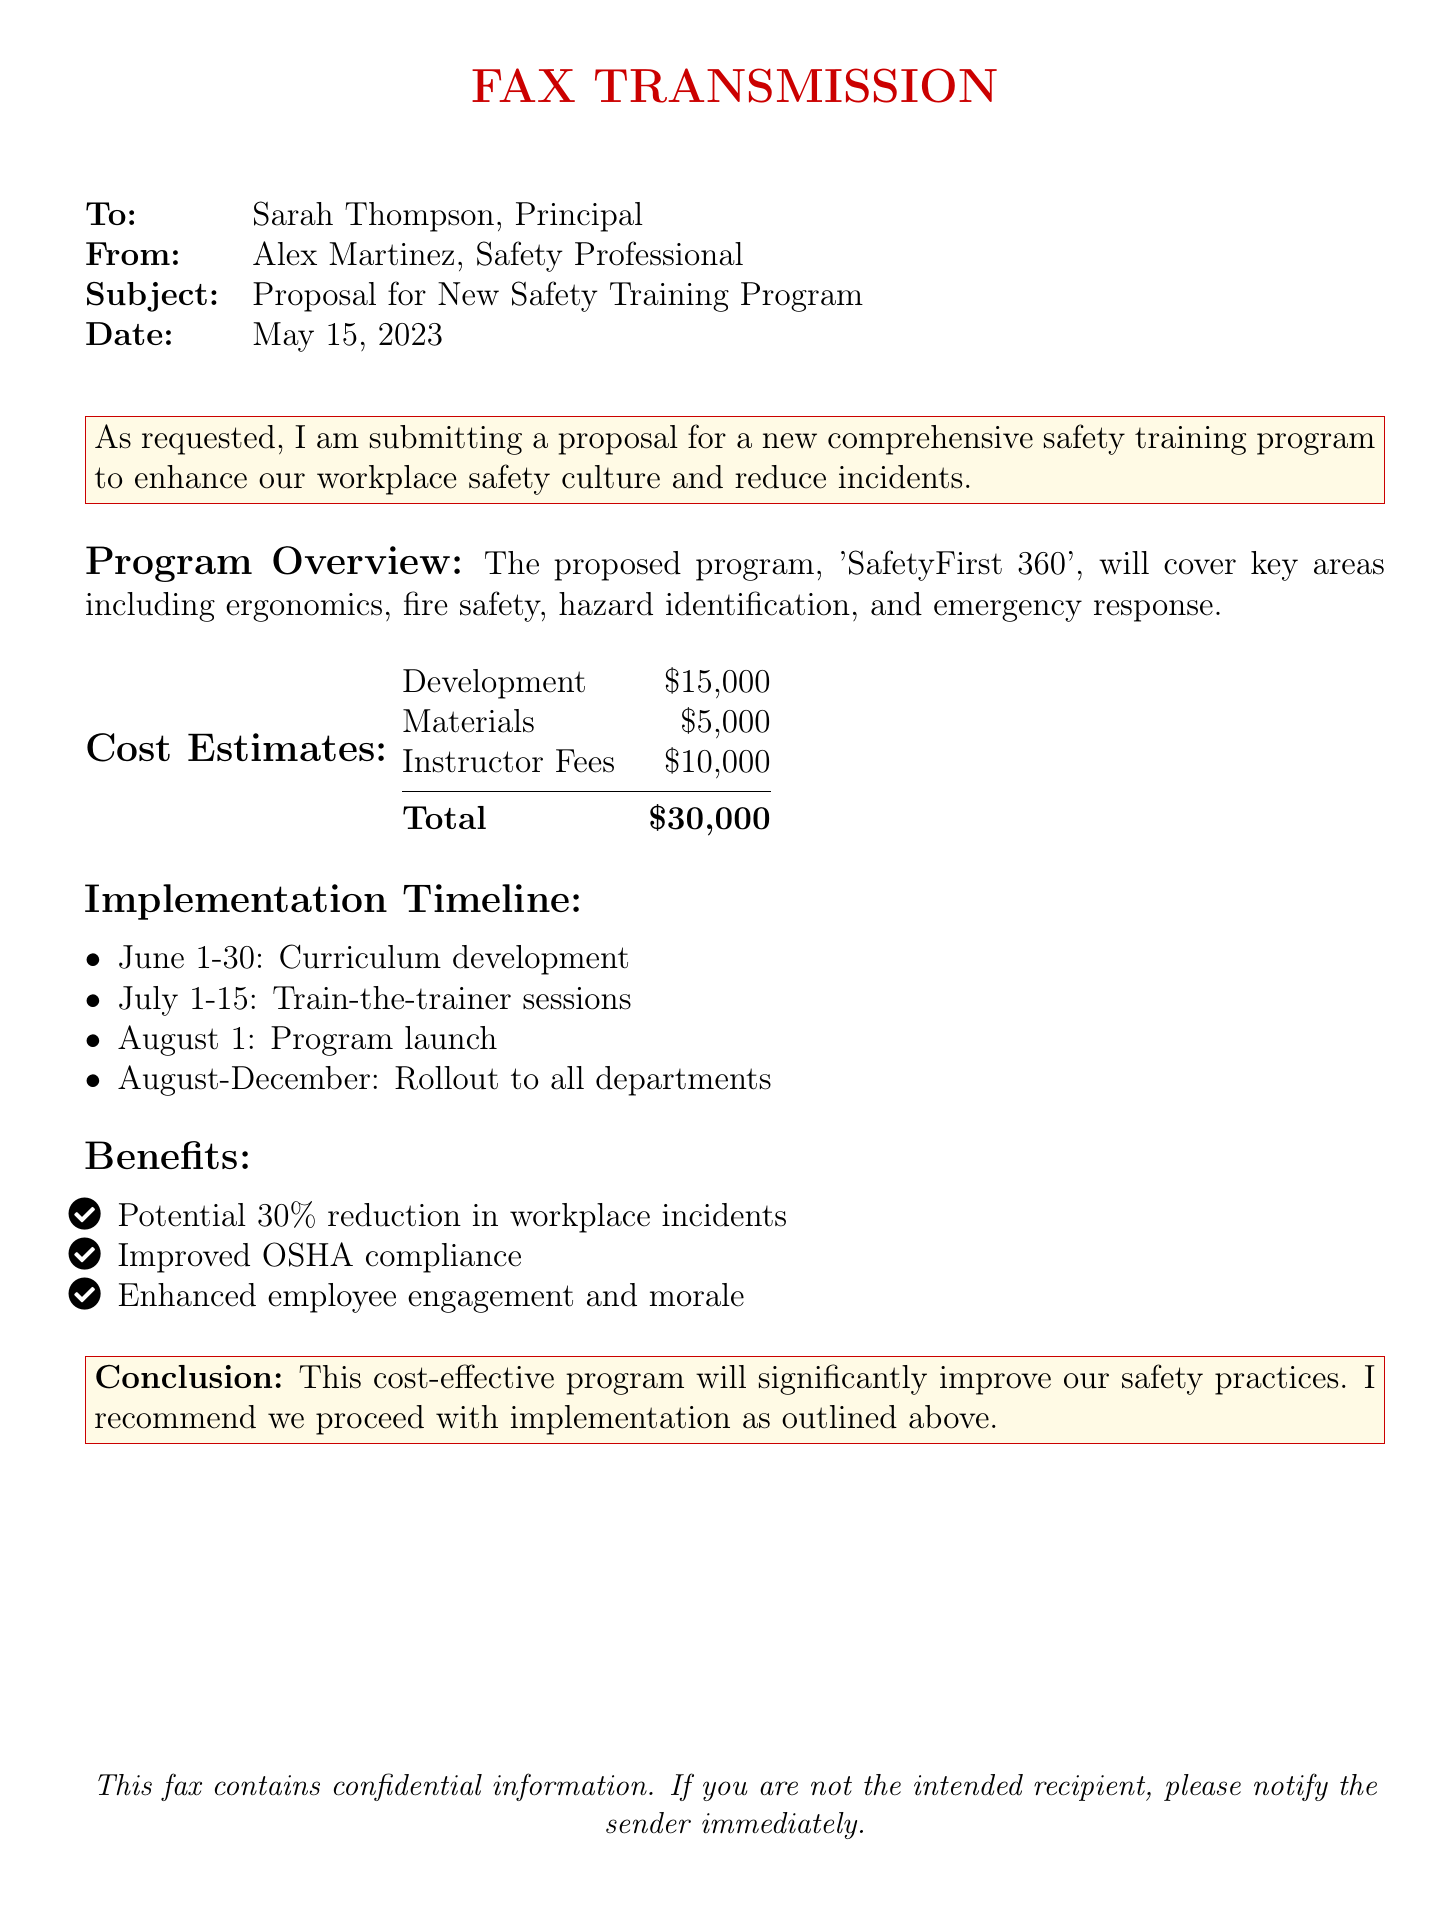What is the subject of the fax? The subject of the fax is indicated clearly in the document as "Proposal for New Safety Training Program."
Answer: Proposal for New Safety Training Program Who is the sender of the fax? The sender's name is located in the 'From' field of the document, which lists "Alex Martinez, Safety Professional."
Answer: Alex Martinez What is the total cost estimate for the program? The total cost estimate sums up the individual cost items presented in the document.
Answer: $30,000 When is the program launch planned? The launch date is specified in the Implementation Timeline section of the document as "August 1."
Answer: August 1 What percentage reduction in workplace incidents is projected? The anticipated percentage reduction is mentioned under the Benefits section of the document.
Answer: 30% How long is the curriculum development phase scheduled to last? The duration for curriculum development is outlined in the Implementation Timeline as spanning "June 1-30."
Answer: June 1-30 What benefit is mentioned concerning OSHA compliance? The benefit related to OSHA compliance is noted in the Benefits section as an improvement.
Answer: Improved OSHA compliance Which color is used for the headings in the document? The color used for headings is described in the code and visually represented, and is "safetyred."
Answer: safetyred 